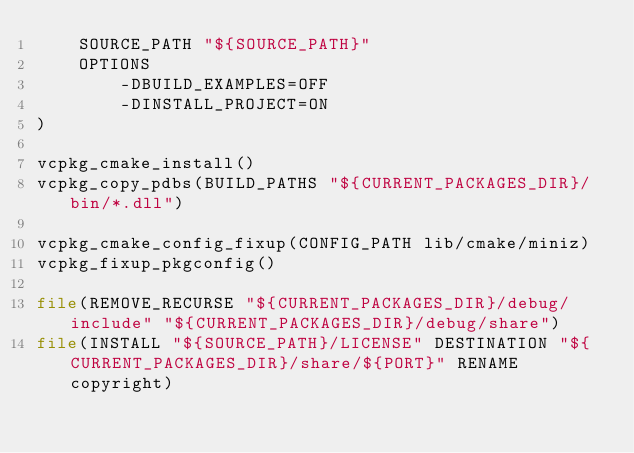Convert code to text. <code><loc_0><loc_0><loc_500><loc_500><_CMake_>    SOURCE_PATH "${SOURCE_PATH}"
    OPTIONS
        -DBUILD_EXAMPLES=OFF
        -DINSTALL_PROJECT=ON
)

vcpkg_cmake_install()
vcpkg_copy_pdbs(BUILD_PATHS "${CURRENT_PACKAGES_DIR}/bin/*.dll")

vcpkg_cmake_config_fixup(CONFIG_PATH lib/cmake/miniz)
vcpkg_fixup_pkgconfig()

file(REMOVE_RECURSE "${CURRENT_PACKAGES_DIR}/debug/include" "${CURRENT_PACKAGES_DIR}/debug/share")
file(INSTALL "${SOURCE_PATH}/LICENSE" DESTINATION "${CURRENT_PACKAGES_DIR}/share/${PORT}" RENAME copyright)
</code> 